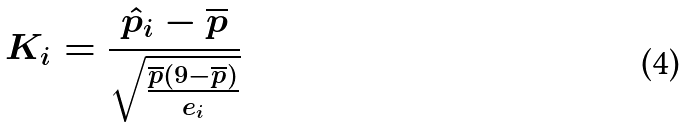<formula> <loc_0><loc_0><loc_500><loc_500>K _ { i } = \frac { \hat { p } _ { i } - \overline { p } } { \sqrt { \frac { \overline { p } ( 9 - \overline { p } ) } { e _ { i } } } }</formula> 